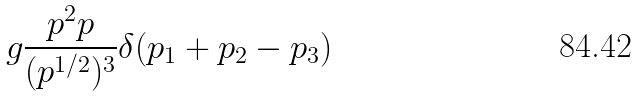Convert formula to latex. <formula><loc_0><loc_0><loc_500><loc_500>g \frac { p ^ { 2 } p } { ( p ^ { 1 / 2 } ) ^ { 3 } } \delta ( p _ { 1 } + p _ { 2 } - p _ { 3 } )</formula> 